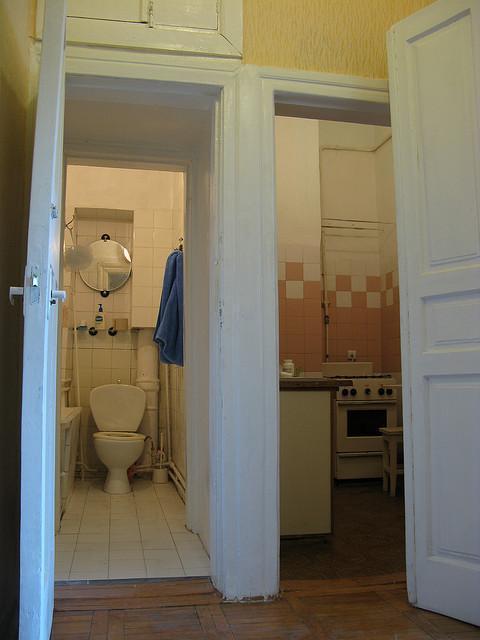How many locks are on the door?
Give a very brief answer. 1. 